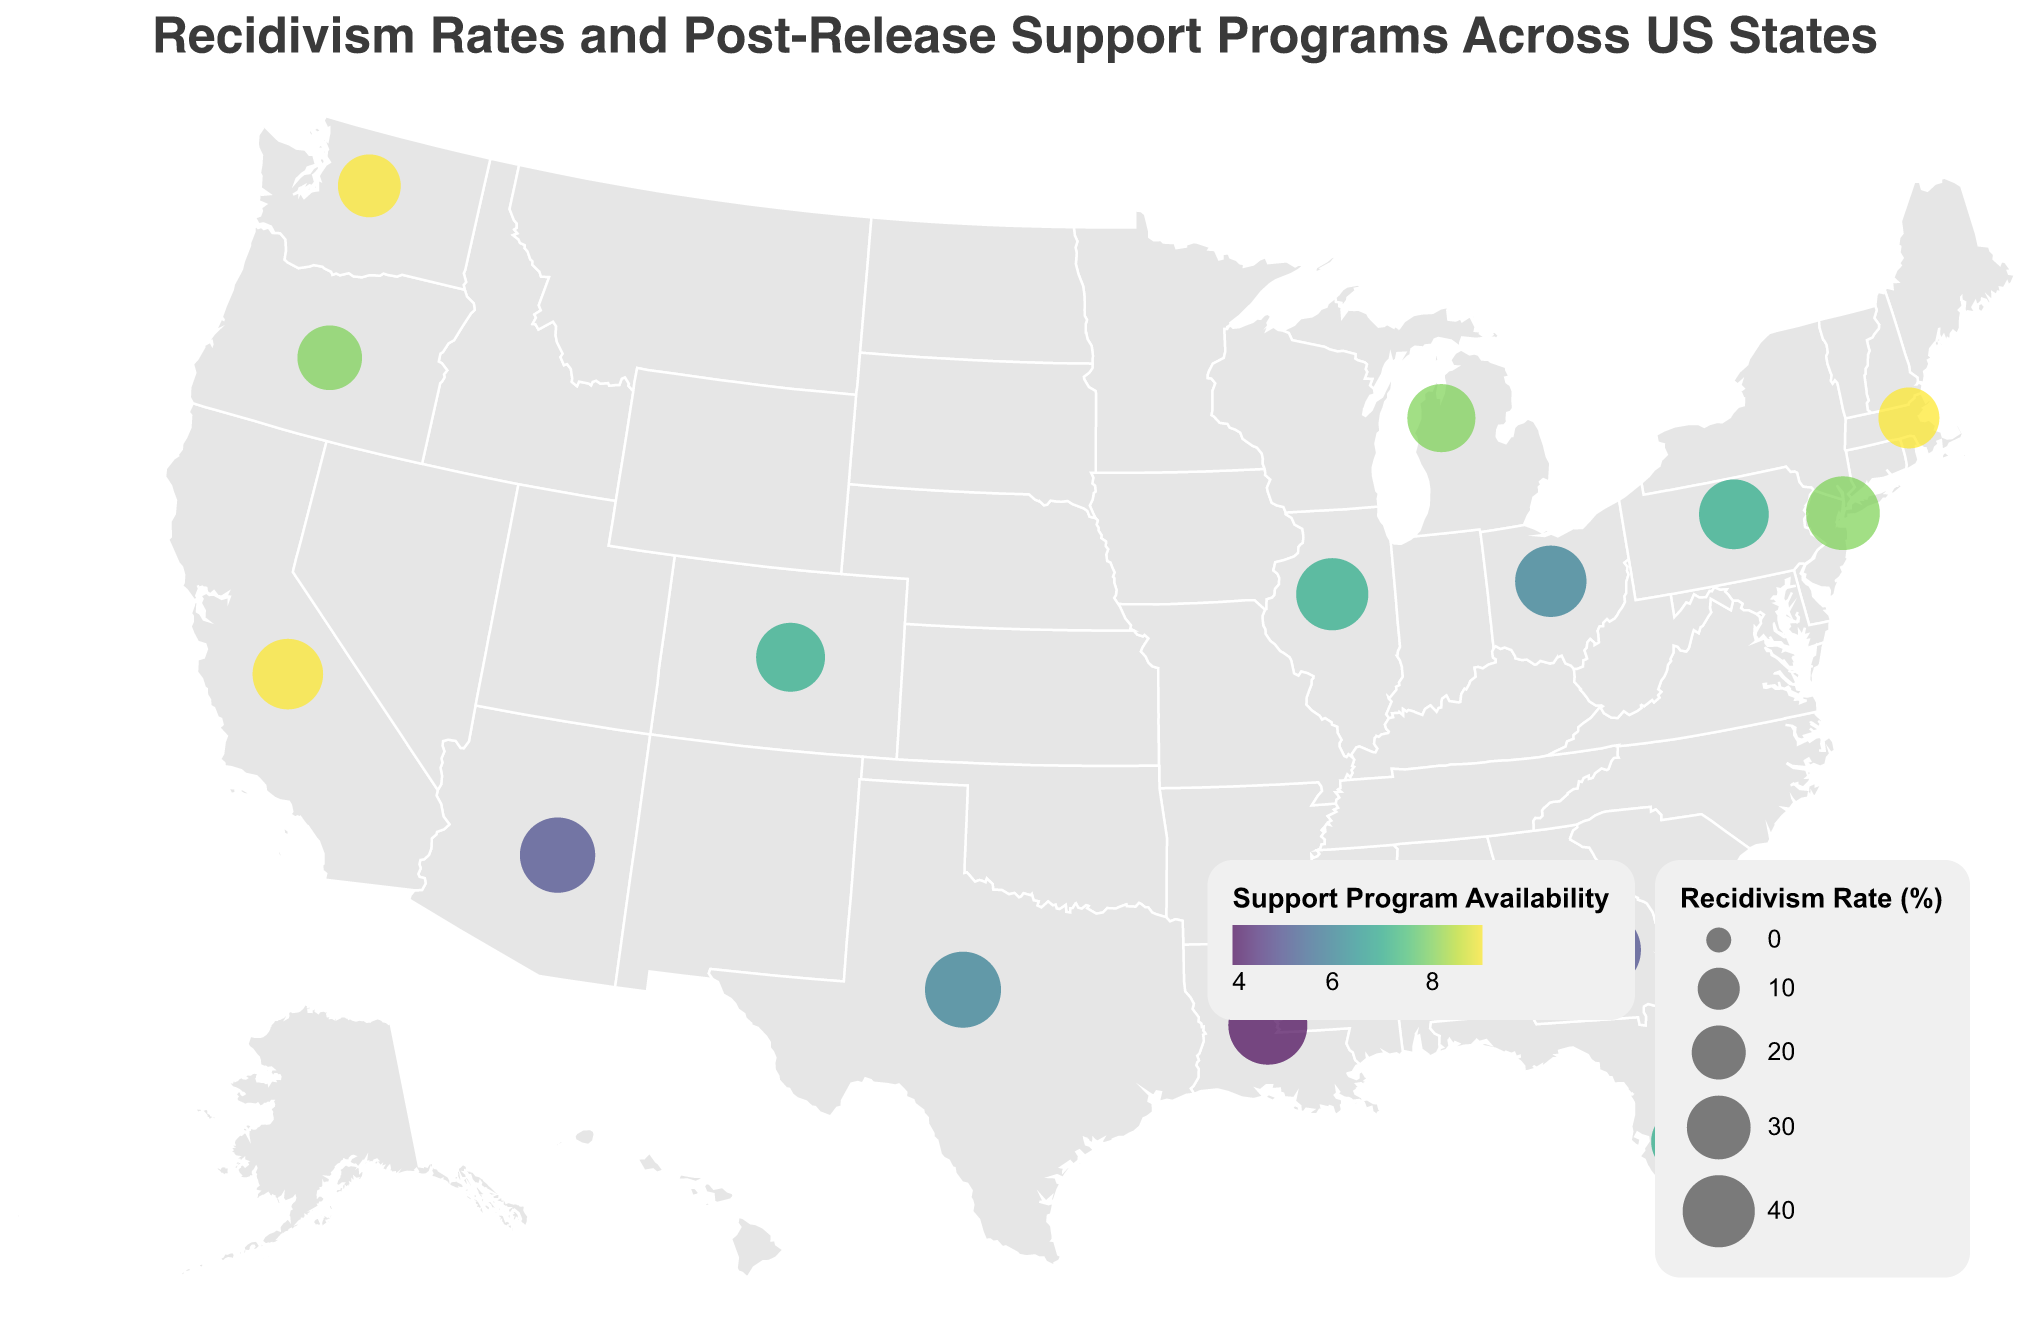What state has the highest recidivism rate? The figure shows circles representing the recidivism rates, with the size of the circles indicating the rate magnitude. Louisiana has the largest circle, indicating the highest recidivism rate.
Answer: Louisiana Which state has the lowest recidivism rate? The figure depicts the state with the smallest circle for the recidivism rate. Massachusetts has the smallest circle, indicating the lowest rate.
Answer: Massachusetts How does Texas's recidivism rate compare to California's? Texas and California are identified on the map, with the sizes of their respective circles comparing their recidivism rates. Texas has a larger circle than California, indicating a higher rate.
Answer: Texas has a higher recidivism rate than California What is the color indicating the highest availability of post-release support programs? The figure uses a viridis color scheme to represent support program availability. The highest support availability (9) is shown in a bright yellow-green color.
Answer: Bright yellow-green How many states have recidivism rates higher than 40%? From the figure, the states with circles larger than others represent higher recidivism rates. By counting these, we find that New York, Texas, Illinois, Georgia, Arizona, and Louisiana have rates above 40%.
Answer: 6 states Is there a correlation between recidivism rates and post-release support program availability? By examining the size of the circles (indicating recidivism rates) and their color (indicating support program availability), we can infer a trend. States with higher support program availability generally have smaller circles (lower recidivism rates). Conversely, states with lower support have larger circles.
Answer: Yes, higher support availability correlates with lower recidivism rates Which state has the highest post-release support program availability, and what is its recidivism rate? Massachusetts is colored in bright yellow-green, indicating the highest support program availability of 9. The size of the circle for Massachusetts shows a recidivism rate of 27%.
Answer: Massachusetts, 27% Among Pennsylvania, Ohio, and Illinois, which state has the lowest recidivism rate? The map shows the sizes of the circles for these states. Pennsylvania has a smaller circle compared to Ohio and Illinois, indicating the lowest recidivism rate among the three.
Answer: Pennsylvania What is the average recidivism rate among the states with post-release support program availability scoring 7? The states with a support program availability score of 7 are Florida, Illinois, Pennsylvania, and Colorado. Their recidivism rates are 33%, 40%, 37%, and 36%, respectively. Adding these rates (33 + 40 + 37 + 36) gives 146, and dividing by 4 gives an average of 36.5%.
Answer: 36.5% 